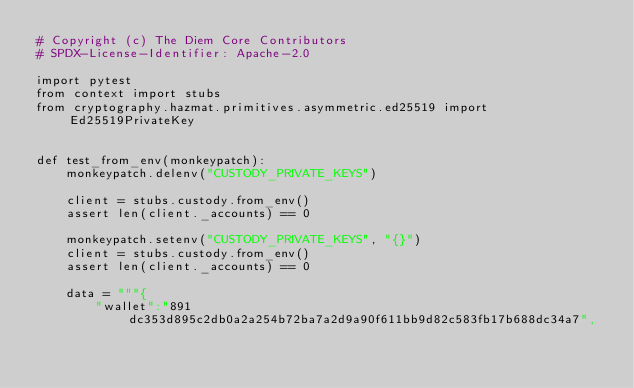Convert code to text. <code><loc_0><loc_0><loc_500><loc_500><_Python_># Copyright (c) The Diem Core Contributors
# SPDX-License-Identifier: Apache-2.0

import pytest
from context import stubs
from cryptography.hazmat.primitives.asymmetric.ed25519 import Ed25519PrivateKey


def test_from_env(monkeypatch):
    monkeypatch.delenv("CUSTODY_PRIVATE_KEYS")

    client = stubs.custody.from_env()
    assert len(client._accounts) == 0

    monkeypatch.setenv("CUSTODY_PRIVATE_KEYS", "{}")
    client = stubs.custody.from_env()
    assert len(client._accounts) == 0

    data = """{
        "wallet":"891dc353d895c2db0a2a254b72ba7a2d9a90f611bb9d82c583fb17b688dc34a7",</code> 